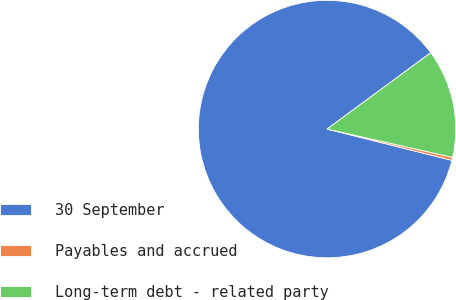<chart> <loc_0><loc_0><loc_500><loc_500><pie_chart><fcel>30 September<fcel>Payables and accrued<fcel>Long-term debt - related party<nl><fcel>85.99%<fcel>0.38%<fcel>13.63%<nl></chart> 